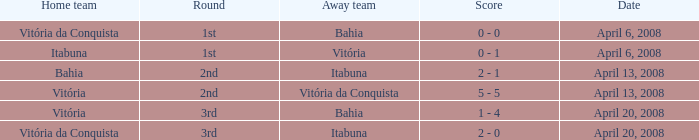Who played as the home team when Vitória was the away team? Itabuna. 